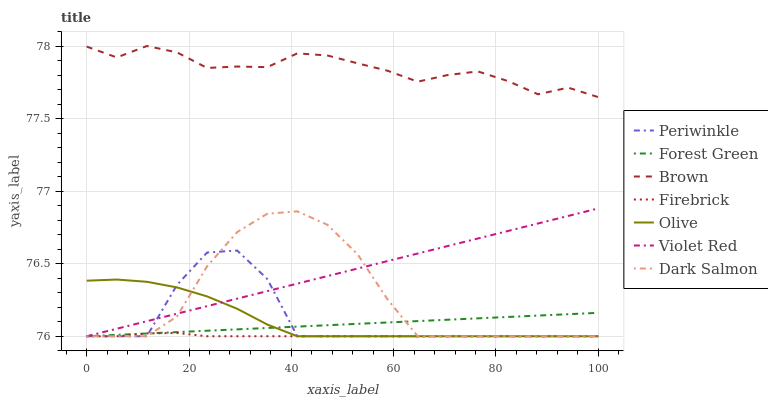Does Firebrick have the minimum area under the curve?
Answer yes or no. Yes. Does Brown have the maximum area under the curve?
Answer yes or no. Yes. Does Violet Red have the minimum area under the curve?
Answer yes or no. No. Does Violet Red have the maximum area under the curve?
Answer yes or no. No. Is Forest Green the smoothest?
Answer yes or no. Yes. Is Periwinkle the roughest?
Answer yes or no. Yes. Is Violet Red the smoothest?
Answer yes or no. No. Is Violet Red the roughest?
Answer yes or no. No. Does Violet Red have the lowest value?
Answer yes or no. Yes. Does Brown have the highest value?
Answer yes or no. Yes. Does Violet Red have the highest value?
Answer yes or no. No. Is Violet Red less than Brown?
Answer yes or no. Yes. Is Brown greater than Periwinkle?
Answer yes or no. Yes. Does Violet Red intersect Forest Green?
Answer yes or no. Yes. Is Violet Red less than Forest Green?
Answer yes or no. No. Is Violet Red greater than Forest Green?
Answer yes or no. No. Does Violet Red intersect Brown?
Answer yes or no. No. 